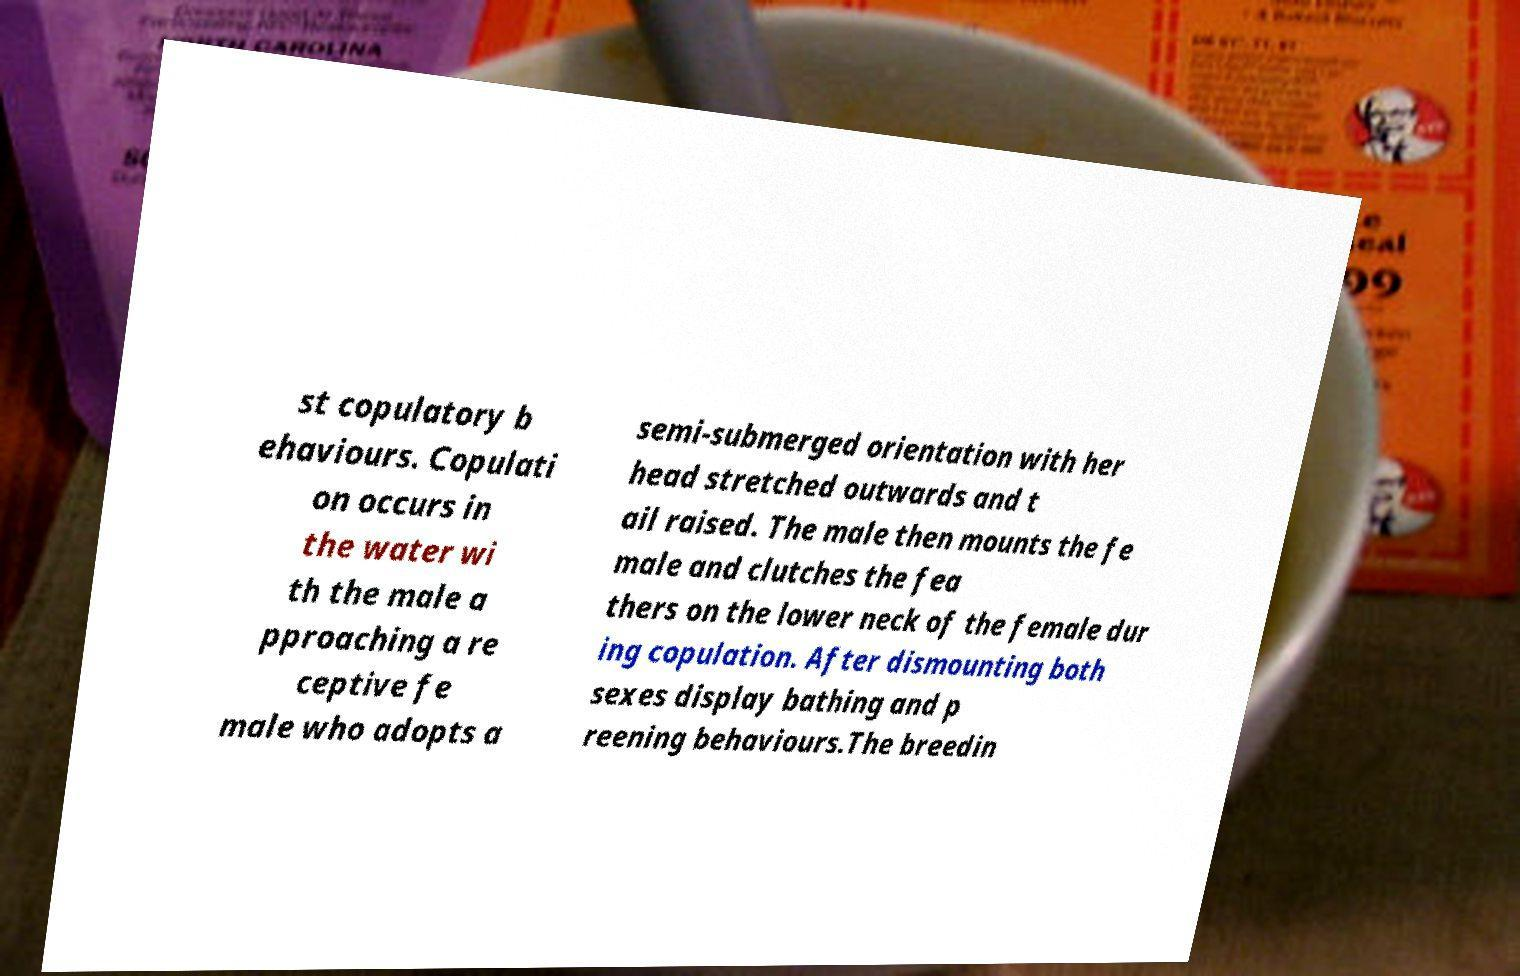What messages or text are displayed in this image? I need them in a readable, typed format. st copulatory b ehaviours. Copulati on occurs in the water wi th the male a pproaching a re ceptive fe male who adopts a semi-submerged orientation with her head stretched outwards and t ail raised. The male then mounts the fe male and clutches the fea thers on the lower neck of the female dur ing copulation. After dismounting both sexes display bathing and p reening behaviours.The breedin 